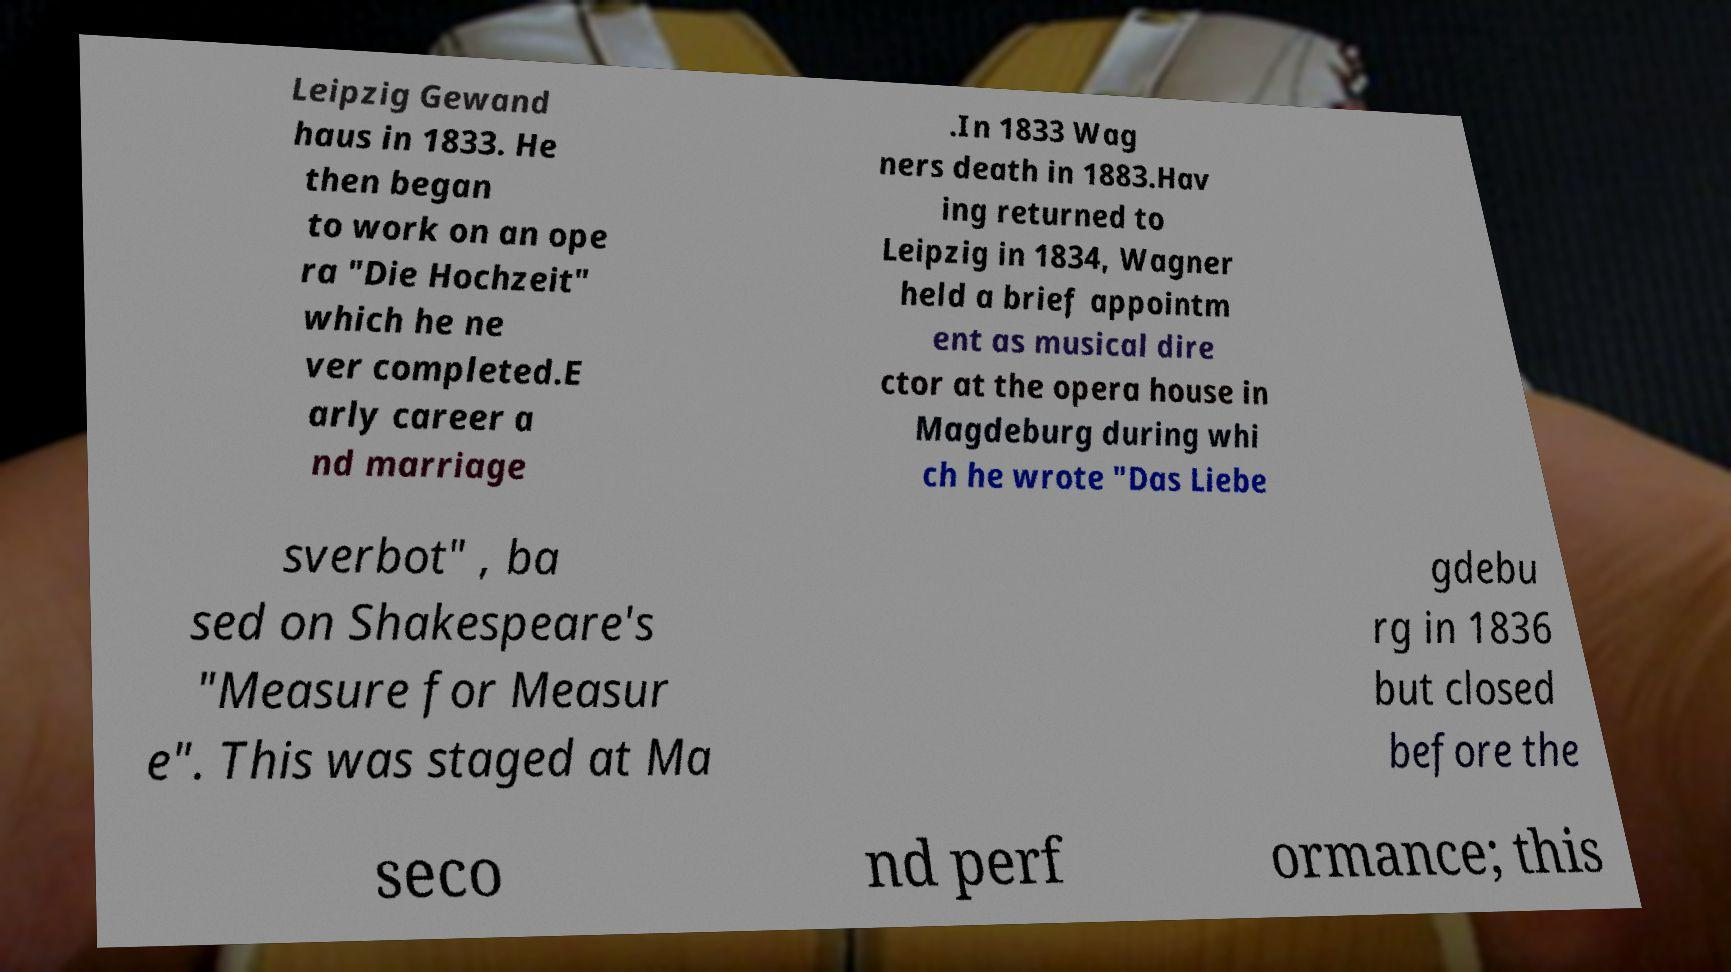Please identify and transcribe the text found in this image. Leipzig Gewand haus in 1833. He then began to work on an ope ra "Die Hochzeit" which he ne ver completed.E arly career a nd marriage .In 1833 Wag ners death in 1883.Hav ing returned to Leipzig in 1834, Wagner held a brief appointm ent as musical dire ctor at the opera house in Magdeburg during whi ch he wrote "Das Liebe sverbot" , ba sed on Shakespeare's "Measure for Measur e". This was staged at Ma gdebu rg in 1836 but closed before the seco nd perf ormance; this 